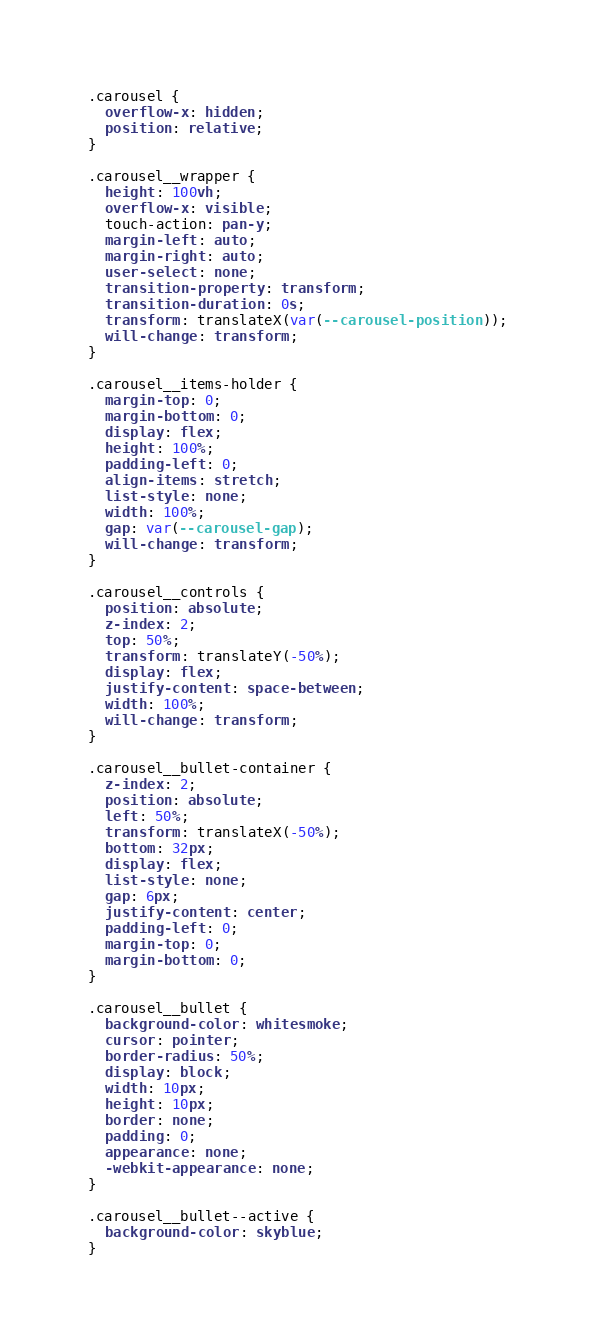<code> <loc_0><loc_0><loc_500><loc_500><_CSS_>.carousel {
  overflow-x: hidden;
  position: relative;
}

.carousel__wrapper {
  height: 100vh;
  overflow-x: visible;
  touch-action: pan-y;
  margin-left: auto;
  margin-right: auto;
  user-select: none;
  transition-property: transform;
  transition-duration: 0s;
  transform: translateX(var(--carousel-position));
  will-change: transform;
}

.carousel__items-holder {
  margin-top: 0;
  margin-bottom: 0;
  display: flex;
  height: 100%;
  padding-left: 0;
  align-items: stretch;
  list-style: none;
  width: 100%;
  gap: var(--carousel-gap);
  will-change: transform;
}

.carousel__controls {
  position: absolute;
  z-index: 2;
  top: 50%;
  transform: translateY(-50%);
  display: flex;
  justify-content: space-between;
  width: 100%;
  will-change: transform;
}

.carousel__bullet-container {
  z-index: 2;
  position: absolute;
  left: 50%;
  transform: translateX(-50%);
  bottom: 32px;
  display: flex;
  list-style: none;
  gap: 6px;
  justify-content: center;
  padding-left: 0;
  margin-top: 0;
  margin-bottom: 0;
}

.carousel__bullet {
  background-color: whitesmoke;
  cursor: pointer;
  border-radius: 50%;
  display: block;
  width: 10px;
  height: 10px;
  border: none;
  padding: 0;
  appearance: none;
  -webkit-appearance: none;
}

.carousel__bullet--active {
  background-color: skyblue;
}
</code> 